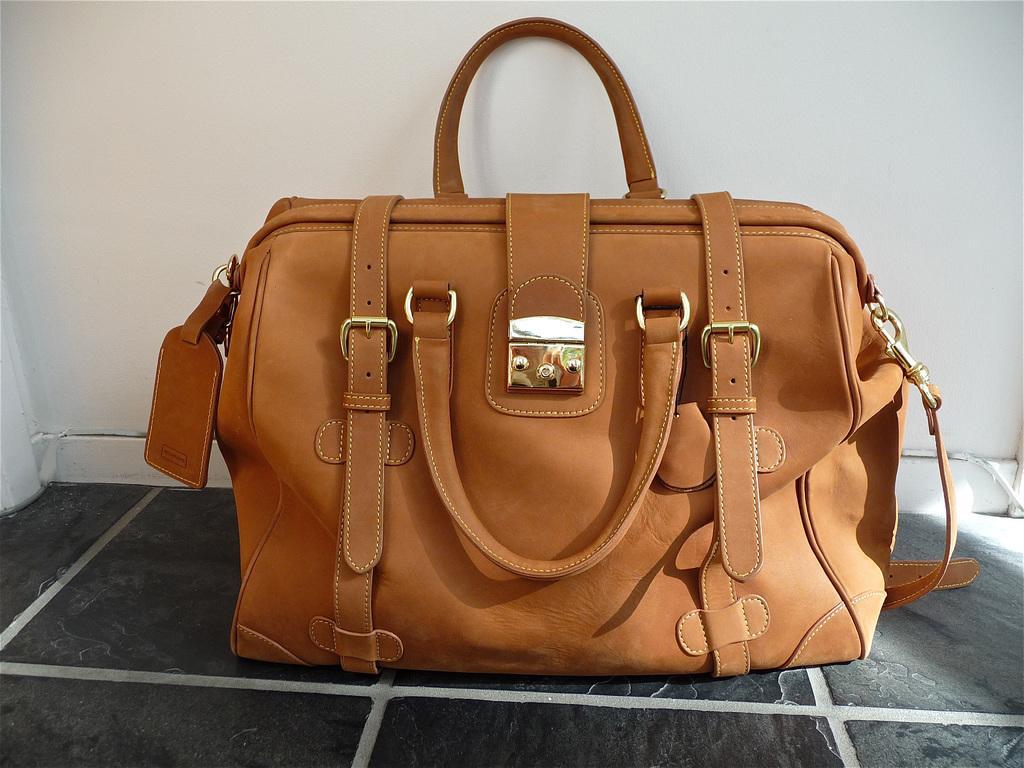Please provide a concise description of this image. There is a brown color bag with belts. 